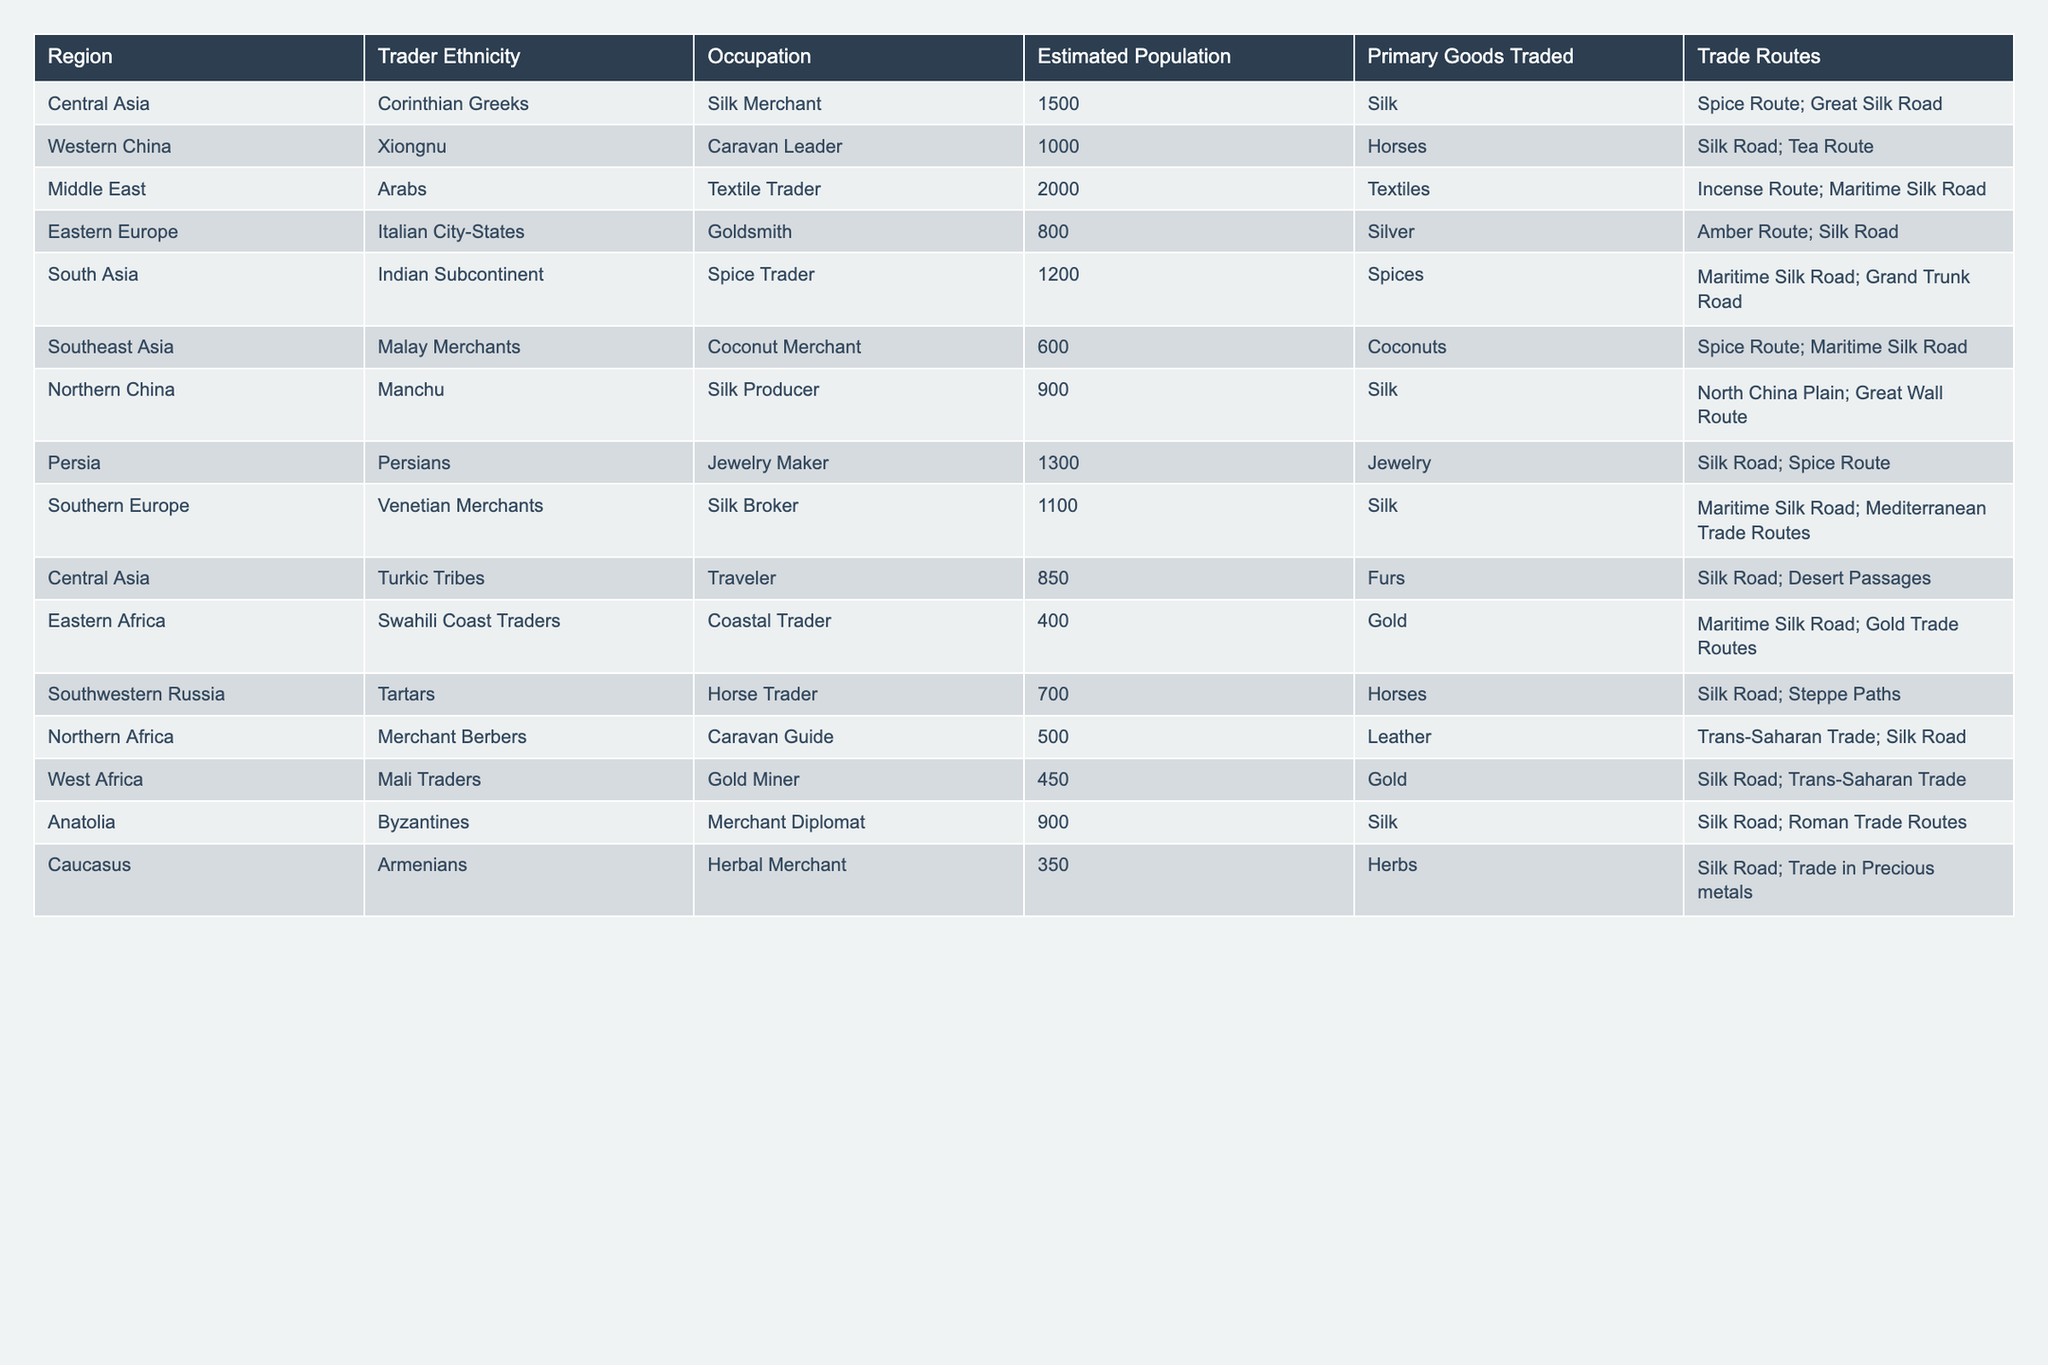What is the estimated population of Arabs in the Middle East? According to the table, the estimated population of Arabs, who are identified as textile traders in the Middle East, is listed as 2000.
Answer: 2000 Which region has the highest estimated population of traders? Upon inspecting the table, the Middle East is shown to have the highest estimated population of traders at 2000.
Answer: Middle East What is the primary good traded by Xiongnu traders in Western China? The table states that the primary goods traded by Xiongnu traders in Western China are horses.
Answer: Horses How many silk producers are there in Northern China according to the table? The table indicates that there are 900 silk producers from Manchu ethnicity in Northern China.
Answer: 900 What is the difference between the estimated populations of Persian jewelry makers and Malay coconut merchants? The estimated population of Persian jewelry makers is 1300, and the Malay coconut merchants are 600. The difference is 1300 - 600 = 700.
Answer: 700 What is the total estimated population of traders in Central Asia? Central Asia has two trader groups listed: Corinthian Greeks with 1500 and Turkic Tribes with 850, yielding a total of 1500 + 850 = 2350.
Answer: 2350 Is it true that the Southern Europe region has a higher population of traders than Northern Africa? Southern Europe has 1100 traders while Northern Africa has 500. Therefore, it is true that Southern Europe has a higher population.
Answer: True Which ethnic group trades primarily in spices, and what is their estimated population? Indian Subcontinent traders are listed as spice traders, with an estimated population of 1200.
Answer: Indian Subcontinent, 1200 What is the average estimated population of traders across all regions in the table? The total estimated population of all traders is 12,350 with 12 groups; dividing 12,350 by 12 gives an average of approximately 1029.17.
Answer: Approximately 1029 Which two regions have horse traders, and how many are estimated in each? Southwestern Russia lists 700 horse traders, and Western China lists 1000 horse traders.
Answer: Southwestern Russia: 700, Western China: 1000 